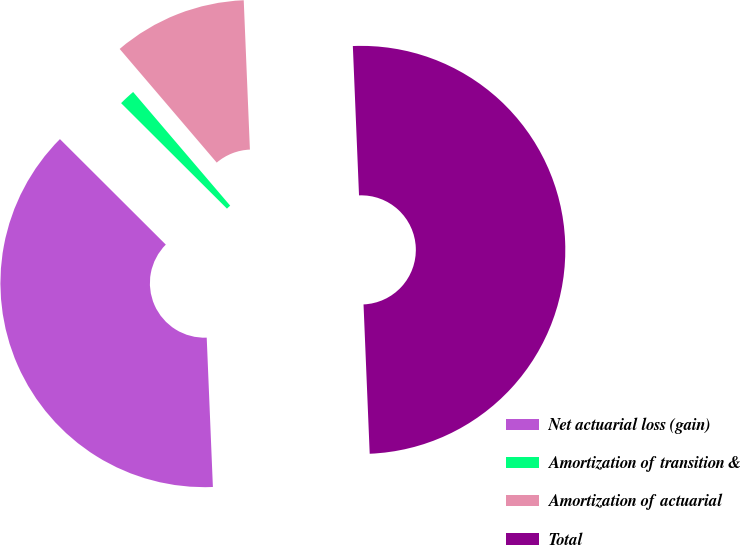Convert chart to OTSL. <chart><loc_0><loc_0><loc_500><loc_500><pie_chart><fcel>Net actuarial loss (gain)<fcel>Amortization of transition &<fcel>Amortization of actuarial<fcel>Total<nl><fcel>38.13%<fcel>1.28%<fcel>10.59%<fcel>50.0%<nl></chart> 